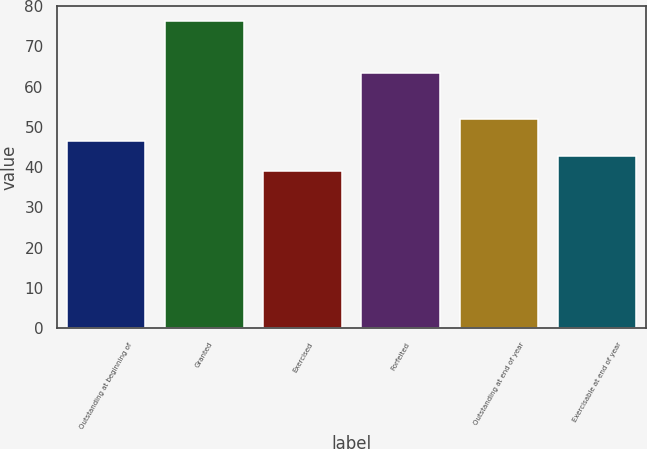Convert chart to OTSL. <chart><loc_0><loc_0><loc_500><loc_500><bar_chart><fcel>Outstanding at beginning of<fcel>Granted<fcel>Exercised<fcel>Forfeited<fcel>Outstanding at end of year<fcel>Exercisable at end of year<nl><fcel>46.56<fcel>76.21<fcel>39.14<fcel>63.27<fcel>51.96<fcel>42.85<nl></chart> 